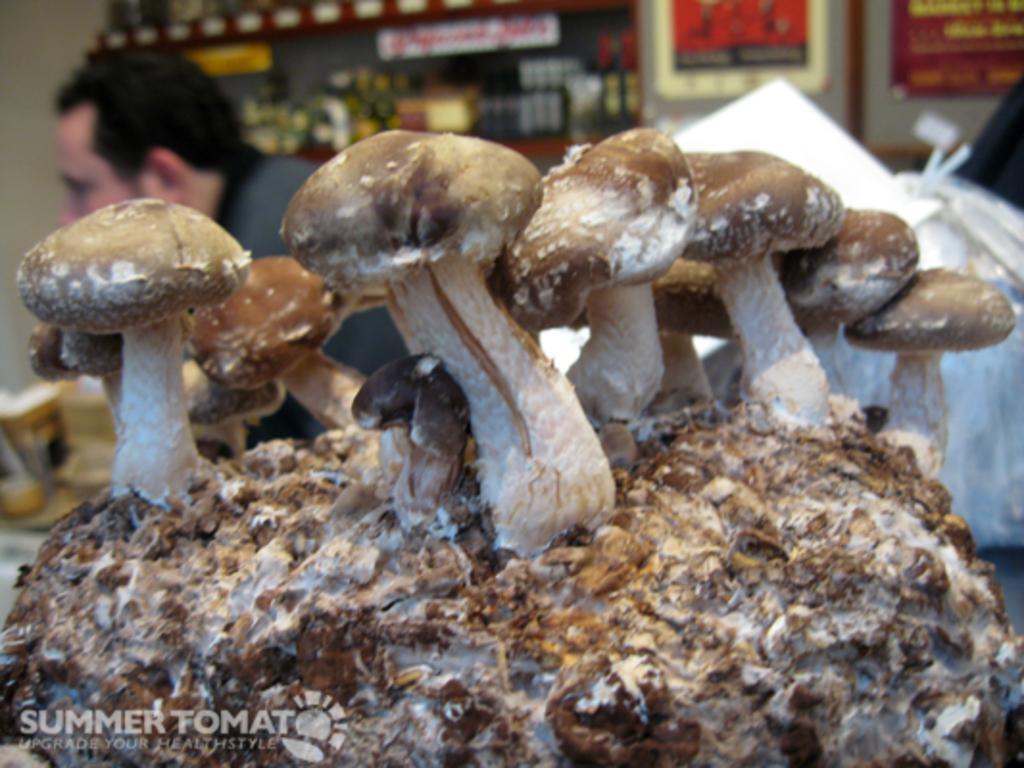Could you give a brief overview of what you see in this image? In this image I can see few mushrooms which are brown, black, cream and white in color on the object which is brown and cream in color. In the background I can see a person, the wall, few white colored plastic bags and few other objects. 